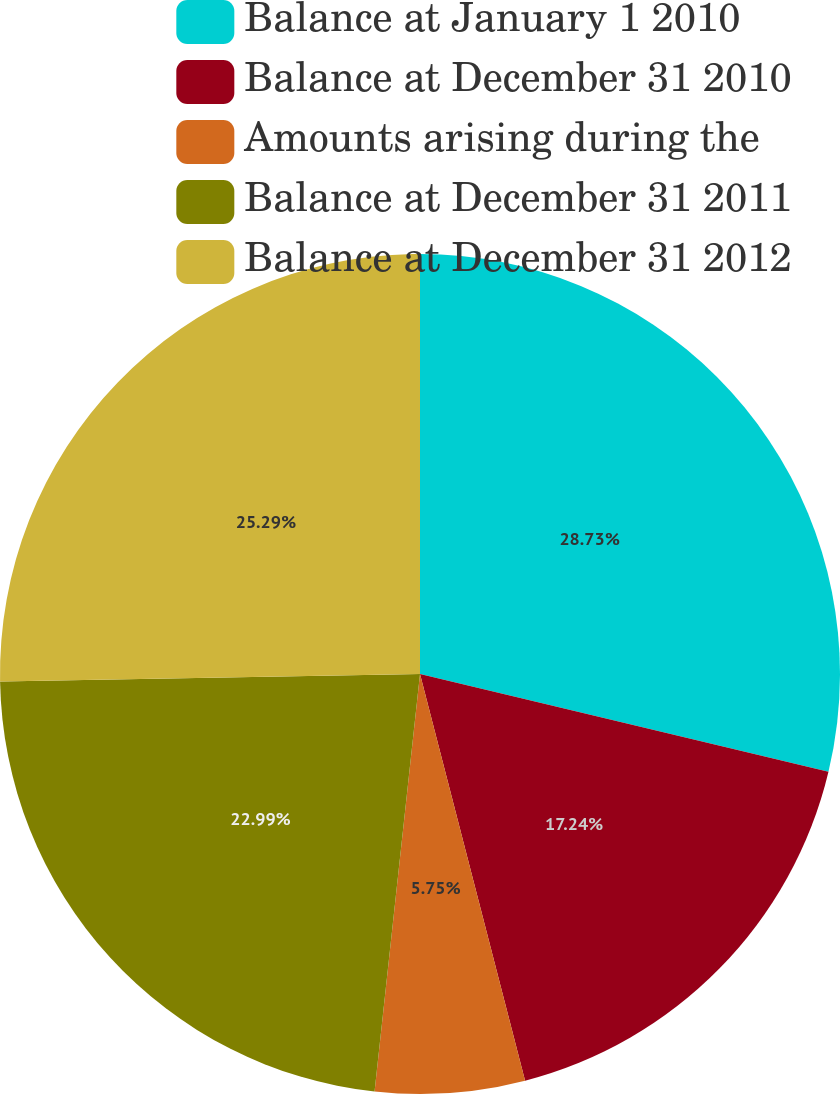<chart> <loc_0><loc_0><loc_500><loc_500><pie_chart><fcel>Balance at January 1 2010<fcel>Balance at December 31 2010<fcel>Amounts arising during the<fcel>Balance at December 31 2011<fcel>Balance at December 31 2012<nl><fcel>28.74%<fcel>17.24%<fcel>5.75%<fcel>22.99%<fcel>25.29%<nl></chart> 